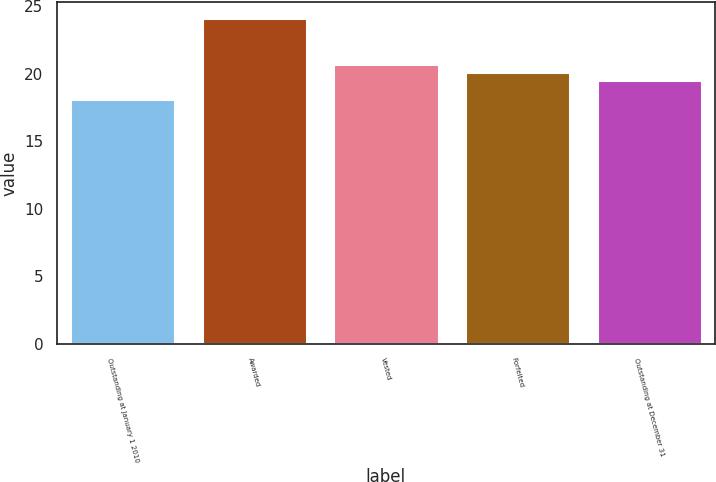Convert chart. <chart><loc_0><loc_0><loc_500><loc_500><bar_chart><fcel>Outstanding at January 1 2010<fcel>Awarded<fcel>Vested<fcel>Forfeited<fcel>Outstanding at December 31<nl><fcel>18.13<fcel>24.12<fcel>20.75<fcel>20.15<fcel>19.55<nl></chart> 